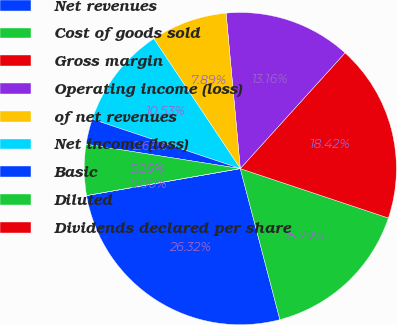Convert chart to OTSL. <chart><loc_0><loc_0><loc_500><loc_500><pie_chart><fcel>Net revenues<fcel>Cost of goods sold<fcel>Gross margin<fcel>Operating income (loss)<fcel>of net revenues<fcel>Net income (loss)<fcel>Basic<fcel>Diluted<fcel>Dividends declared per share<nl><fcel>26.32%<fcel>15.79%<fcel>18.42%<fcel>13.16%<fcel>7.89%<fcel>10.53%<fcel>2.63%<fcel>5.26%<fcel>0.0%<nl></chart> 